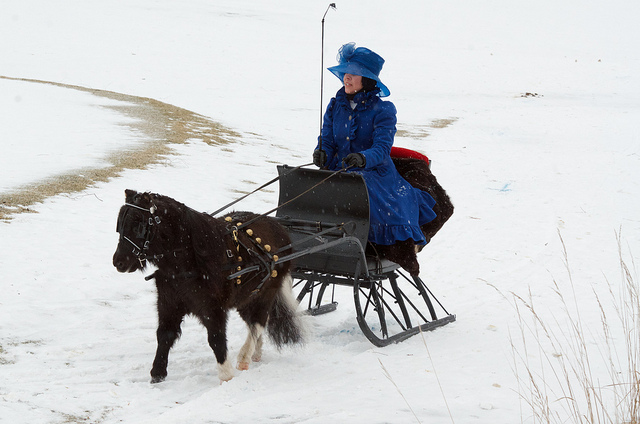Is this a large horse? No, the horse appears to be of a smaller breed, possibly a Shetland pony, which is known for its sturdy build and smaller stature. 